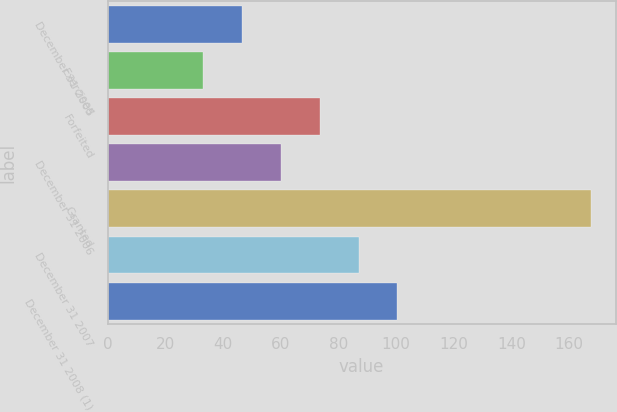Convert chart to OTSL. <chart><loc_0><loc_0><loc_500><loc_500><bar_chart><fcel>December 31 2005<fcel>Exercised<fcel>Forfeited<fcel>December 31 2006<fcel>Granted<fcel>December 31 2007<fcel>December 31 2008 (1)<nl><fcel>46.68<fcel>33.23<fcel>73.58<fcel>60.13<fcel>167.76<fcel>87.03<fcel>100.48<nl></chart> 